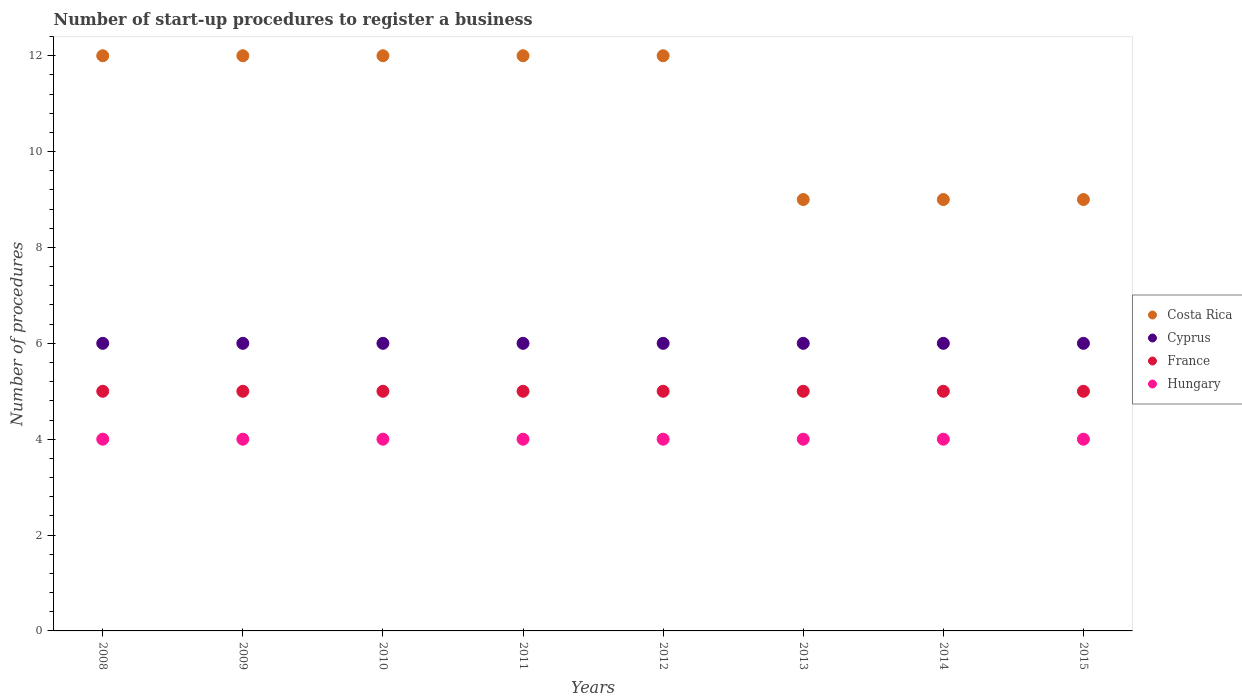Is the number of dotlines equal to the number of legend labels?
Offer a terse response. Yes. What is the number of procedures required to register a business in Hungary in 2010?
Your answer should be compact. 4. Across all years, what is the maximum number of procedures required to register a business in France?
Keep it short and to the point. 5. Across all years, what is the minimum number of procedures required to register a business in Cyprus?
Give a very brief answer. 6. In which year was the number of procedures required to register a business in Cyprus minimum?
Your answer should be compact. 2008. What is the total number of procedures required to register a business in Cyprus in the graph?
Keep it short and to the point. 48. What is the difference between the number of procedures required to register a business in Cyprus in 2010 and that in 2011?
Your answer should be compact. 0. What is the average number of procedures required to register a business in Costa Rica per year?
Offer a very short reply. 10.88. In how many years, is the number of procedures required to register a business in Hungary greater than 10.4?
Provide a succinct answer. 0. Is the difference between the number of procedures required to register a business in Hungary in 2013 and 2014 greater than the difference between the number of procedures required to register a business in Cyprus in 2013 and 2014?
Make the answer very short. No. What is the difference between the highest and the lowest number of procedures required to register a business in Costa Rica?
Offer a very short reply. 3. In how many years, is the number of procedures required to register a business in Cyprus greater than the average number of procedures required to register a business in Cyprus taken over all years?
Make the answer very short. 0. Does the number of procedures required to register a business in Costa Rica monotonically increase over the years?
Make the answer very short. No. Is the number of procedures required to register a business in Hungary strictly greater than the number of procedures required to register a business in France over the years?
Make the answer very short. No. How many dotlines are there?
Provide a short and direct response. 4. What is the difference between two consecutive major ticks on the Y-axis?
Offer a very short reply. 2. Does the graph contain any zero values?
Provide a succinct answer. No. What is the title of the graph?
Offer a very short reply. Number of start-up procedures to register a business. What is the label or title of the Y-axis?
Give a very brief answer. Number of procedures. What is the Number of procedures of France in 2008?
Offer a terse response. 5. What is the Number of procedures in Hungary in 2008?
Ensure brevity in your answer.  4. What is the Number of procedures in Costa Rica in 2009?
Make the answer very short. 12. What is the Number of procedures in Cyprus in 2009?
Make the answer very short. 6. What is the Number of procedures in France in 2010?
Give a very brief answer. 5. What is the Number of procedures in Hungary in 2010?
Ensure brevity in your answer.  4. What is the Number of procedures of Cyprus in 2011?
Make the answer very short. 6. What is the Number of procedures of France in 2011?
Provide a short and direct response. 5. What is the Number of procedures of Costa Rica in 2012?
Provide a short and direct response. 12. What is the Number of procedures in France in 2012?
Ensure brevity in your answer.  5. What is the Number of procedures of Costa Rica in 2013?
Keep it short and to the point. 9. What is the Number of procedures in Hungary in 2013?
Provide a short and direct response. 4. What is the Number of procedures of Cyprus in 2014?
Ensure brevity in your answer.  6. What is the Number of procedures in Costa Rica in 2015?
Offer a very short reply. 9. What is the Number of procedures of Cyprus in 2015?
Give a very brief answer. 6. Across all years, what is the maximum Number of procedures of France?
Give a very brief answer. 5. Across all years, what is the maximum Number of procedures of Hungary?
Keep it short and to the point. 4. Across all years, what is the minimum Number of procedures of Costa Rica?
Offer a very short reply. 9. What is the total Number of procedures in France in the graph?
Provide a succinct answer. 40. What is the difference between the Number of procedures of Costa Rica in 2008 and that in 2009?
Provide a short and direct response. 0. What is the difference between the Number of procedures in Cyprus in 2008 and that in 2010?
Ensure brevity in your answer.  0. What is the difference between the Number of procedures of France in 2008 and that in 2010?
Make the answer very short. 0. What is the difference between the Number of procedures in France in 2008 and that in 2011?
Keep it short and to the point. 0. What is the difference between the Number of procedures of Hungary in 2008 and that in 2011?
Your answer should be very brief. 0. What is the difference between the Number of procedures of Costa Rica in 2008 and that in 2012?
Provide a short and direct response. 0. What is the difference between the Number of procedures of Cyprus in 2008 and that in 2012?
Give a very brief answer. 0. What is the difference between the Number of procedures in France in 2008 and that in 2012?
Provide a short and direct response. 0. What is the difference between the Number of procedures of France in 2008 and that in 2013?
Your answer should be compact. 0. What is the difference between the Number of procedures of Hungary in 2008 and that in 2013?
Your answer should be compact. 0. What is the difference between the Number of procedures of Hungary in 2008 and that in 2014?
Make the answer very short. 0. What is the difference between the Number of procedures in Costa Rica in 2009 and that in 2010?
Give a very brief answer. 0. What is the difference between the Number of procedures of France in 2009 and that in 2010?
Make the answer very short. 0. What is the difference between the Number of procedures of Cyprus in 2009 and that in 2011?
Offer a very short reply. 0. What is the difference between the Number of procedures in France in 2009 and that in 2011?
Give a very brief answer. 0. What is the difference between the Number of procedures of Hungary in 2009 and that in 2011?
Offer a terse response. 0. What is the difference between the Number of procedures of Costa Rica in 2009 and that in 2012?
Offer a very short reply. 0. What is the difference between the Number of procedures of Cyprus in 2009 and that in 2012?
Keep it short and to the point. 0. What is the difference between the Number of procedures in Costa Rica in 2009 and that in 2013?
Your answer should be very brief. 3. What is the difference between the Number of procedures of France in 2009 and that in 2014?
Your answer should be very brief. 0. What is the difference between the Number of procedures in Hungary in 2009 and that in 2015?
Your response must be concise. 0. What is the difference between the Number of procedures in Costa Rica in 2010 and that in 2011?
Keep it short and to the point. 0. What is the difference between the Number of procedures of Hungary in 2010 and that in 2011?
Keep it short and to the point. 0. What is the difference between the Number of procedures in Cyprus in 2010 and that in 2012?
Provide a succinct answer. 0. What is the difference between the Number of procedures of Hungary in 2010 and that in 2012?
Offer a terse response. 0. What is the difference between the Number of procedures of Costa Rica in 2010 and that in 2013?
Give a very brief answer. 3. What is the difference between the Number of procedures of Cyprus in 2010 and that in 2013?
Make the answer very short. 0. What is the difference between the Number of procedures in Hungary in 2010 and that in 2013?
Make the answer very short. 0. What is the difference between the Number of procedures in Costa Rica in 2010 and that in 2014?
Offer a very short reply. 3. What is the difference between the Number of procedures in Hungary in 2010 and that in 2014?
Provide a short and direct response. 0. What is the difference between the Number of procedures in Costa Rica in 2010 and that in 2015?
Offer a terse response. 3. What is the difference between the Number of procedures of Cyprus in 2010 and that in 2015?
Ensure brevity in your answer.  0. What is the difference between the Number of procedures of Hungary in 2010 and that in 2015?
Give a very brief answer. 0. What is the difference between the Number of procedures in Costa Rica in 2011 and that in 2012?
Your response must be concise. 0. What is the difference between the Number of procedures in Hungary in 2011 and that in 2012?
Your answer should be compact. 0. What is the difference between the Number of procedures in Costa Rica in 2011 and that in 2013?
Ensure brevity in your answer.  3. What is the difference between the Number of procedures in France in 2011 and that in 2014?
Offer a terse response. 0. What is the difference between the Number of procedures in Cyprus in 2011 and that in 2015?
Give a very brief answer. 0. What is the difference between the Number of procedures in Hungary in 2011 and that in 2015?
Make the answer very short. 0. What is the difference between the Number of procedures of France in 2012 and that in 2013?
Offer a terse response. 0. What is the difference between the Number of procedures in France in 2012 and that in 2014?
Offer a very short reply. 0. What is the difference between the Number of procedures in Hungary in 2012 and that in 2015?
Make the answer very short. 0. What is the difference between the Number of procedures in France in 2013 and that in 2014?
Provide a short and direct response. 0. What is the difference between the Number of procedures of France in 2013 and that in 2015?
Provide a short and direct response. 0. What is the difference between the Number of procedures of Cyprus in 2014 and that in 2015?
Your answer should be very brief. 0. What is the difference between the Number of procedures of France in 2014 and that in 2015?
Keep it short and to the point. 0. What is the difference between the Number of procedures in Hungary in 2014 and that in 2015?
Offer a very short reply. 0. What is the difference between the Number of procedures of Costa Rica in 2008 and the Number of procedures of Cyprus in 2009?
Provide a short and direct response. 6. What is the difference between the Number of procedures of Costa Rica in 2008 and the Number of procedures of France in 2009?
Make the answer very short. 7. What is the difference between the Number of procedures of Cyprus in 2008 and the Number of procedures of France in 2009?
Your response must be concise. 1. What is the difference between the Number of procedures of France in 2008 and the Number of procedures of Hungary in 2009?
Provide a succinct answer. 1. What is the difference between the Number of procedures of Costa Rica in 2008 and the Number of procedures of France in 2010?
Your answer should be very brief. 7. What is the difference between the Number of procedures in Costa Rica in 2008 and the Number of procedures in Hungary in 2010?
Make the answer very short. 8. What is the difference between the Number of procedures in Cyprus in 2008 and the Number of procedures in France in 2010?
Offer a terse response. 1. What is the difference between the Number of procedures of Cyprus in 2008 and the Number of procedures of Hungary in 2010?
Provide a short and direct response. 2. What is the difference between the Number of procedures in France in 2008 and the Number of procedures in Hungary in 2010?
Provide a short and direct response. 1. What is the difference between the Number of procedures of Costa Rica in 2008 and the Number of procedures of Cyprus in 2011?
Provide a succinct answer. 6. What is the difference between the Number of procedures of Costa Rica in 2008 and the Number of procedures of France in 2011?
Give a very brief answer. 7. What is the difference between the Number of procedures of Costa Rica in 2008 and the Number of procedures of Hungary in 2011?
Your response must be concise. 8. What is the difference between the Number of procedures in Cyprus in 2008 and the Number of procedures in France in 2011?
Offer a very short reply. 1. What is the difference between the Number of procedures of Costa Rica in 2008 and the Number of procedures of Cyprus in 2012?
Ensure brevity in your answer.  6. What is the difference between the Number of procedures in Cyprus in 2008 and the Number of procedures in Hungary in 2012?
Offer a terse response. 2. What is the difference between the Number of procedures in Costa Rica in 2008 and the Number of procedures in France in 2013?
Make the answer very short. 7. What is the difference between the Number of procedures in France in 2008 and the Number of procedures in Hungary in 2013?
Your answer should be very brief. 1. What is the difference between the Number of procedures in Costa Rica in 2008 and the Number of procedures in Cyprus in 2014?
Give a very brief answer. 6. What is the difference between the Number of procedures of Costa Rica in 2008 and the Number of procedures of Hungary in 2014?
Your response must be concise. 8. What is the difference between the Number of procedures in Cyprus in 2008 and the Number of procedures in France in 2014?
Offer a terse response. 1. What is the difference between the Number of procedures of Cyprus in 2008 and the Number of procedures of Hungary in 2014?
Your answer should be compact. 2. What is the difference between the Number of procedures in Cyprus in 2008 and the Number of procedures in Hungary in 2015?
Make the answer very short. 2. What is the difference between the Number of procedures in France in 2008 and the Number of procedures in Hungary in 2015?
Keep it short and to the point. 1. What is the difference between the Number of procedures in Costa Rica in 2009 and the Number of procedures in Cyprus in 2010?
Offer a very short reply. 6. What is the difference between the Number of procedures in Costa Rica in 2009 and the Number of procedures in France in 2010?
Make the answer very short. 7. What is the difference between the Number of procedures of Cyprus in 2009 and the Number of procedures of Hungary in 2010?
Your response must be concise. 2. What is the difference between the Number of procedures in Cyprus in 2009 and the Number of procedures in Hungary in 2011?
Offer a terse response. 2. What is the difference between the Number of procedures of Costa Rica in 2009 and the Number of procedures of France in 2012?
Give a very brief answer. 7. What is the difference between the Number of procedures in Cyprus in 2009 and the Number of procedures in France in 2013?
Keep it short and to the point. 1. What is the difference between the Number of procedures in Costa Rica in 2009 and the Number of procedures in Cyprus in 2014?
Your answer should be very brief. 6. What is the difference between the Number of procedures in Costa Rica in 2009 and the Number of procedures in France in 2014?
Your response must be concise. 7. What is the difference between the Number of procedures in Costa Rica in 2009 and the Number of procedures in Hungary in 2014?
Offer a terse response. 8. What is the difference between the Number of procedures of Cyprus in 2009 and the Number of procedures of France in 2014?
Your answer should be very brief. 1. What is the difference between the Number of procedures of Cyprus in 2009 and the Number of procedures of Hungary in 2014?
Your response must be concise. 2. What is the difference between the Number of procedures of France in 2009 and the Number of procedures of Hungary in 2014?
Your answer should be compact. 1. What is the difference between the Number of procedures of Costa Rica in 2009 and the Number of procedures of Cyprus in 2015?
Offer a terse response. 6. What is the difference between the Number of procedures of Costa Rica in 2010 and the Number of procedures of Hungary in 2011?
Keep it short and to the point. 8. What is the difference between the Number of procedures of France in 2010 and the Number of procedures of Hungary in 2011?
Your response must be concise. 1. What is the difference between the Number of procedures of Costa Rica in 2010 and the Number of procedures of France in 2012?
Give a very brief answer. 7. What is the difference between the Number of procedures of France in 2010 and the Number of procedures of Hungary in 2012?
Your answer should be compact. 1. What is the difference between the Number of procedures of Costa Rica in 2010 and the Number of procedures of France in 2013?
Keep it short and to the point. 7. What is the difference between the Number of procedures in Cyprus in 2010 and the Number of procedures in France in 2013?
Ensure brevity in your answer.  1. What is the difference between the Number of procedures in France in 2010 and the Number of procedures in Hungary in 2013?
Your response must be concise. 1. What is the difference between the Number of procedures in Costa Rica in 2010 and the Number of procedures in Cyprus in 2014?
Make the answer very short. 6. What is the difference between the Number of procedures in Costa Rica in 2010 and the Number of procedures in Cyprus in 2015?
Make the answer very short. 6. What is the difference between the Number of procedures of Costa Rica in 2010 and the Number of procedures of France in 2015?
Make the answer very short. 7. What is the difference between the Number of procedures in Costa Rica in 2011 and the Number of procedures in Cyprus in 2012?
Your answer should be compact. 6. What is the difference between the Number of procedures of Costa Rica in 2011 and the Number of procedures of France in 2012?
Give a very brief answer. 7. What is the difference between the Number of procedures in Cyprus in 2011 and the Number of procedures in France in 2012?
Offer a terse response. 1. What is the difference between the Number of procedures of Cyprus in 2011 and the Number of procedures of France in 2013?
Offer a very short reply. 1. What is the difference between the Number of procedures of Cyprus in 2011 and the Number of procedures of Hungary in 2013?
Offer a very short reply. 2. What is the difference between the Number of procedures of France in 2011 and the Number of procedures of Hungary in 2013?
Your answer should be very brief. 1. What is the difference between the Number of procedures of Cyprus in 2011 and the Number of procedures of France in 2014?
Offer a terse response. 1. What is the difference between the Number of procedures in Cyprus in 2011 and the Number of procedures in Hungary in 2014?
Make the answer very short. 2. What is the difference between the Number of procedures of France in 2011 and the Number of procedures of Hungary in 2014?
Your answer should be very brief. 1. What is the difference between the Number of procedures in Costa Rica in 2011 and the Number of procedures in France in 2015?
Keep it short and to the point. 7. What is the difference between the Number of procedures of France in 2011 and the Number of procedures of Hungary in 2015?
Offer a very short reply. 1. What is the difference between the Number of procedures of Costa Rica in 2012 and the Number of procedures of France in 2013?
Make the answer very short. 7. What is the difference between the Number of procedures of Costa Rica in 2012 and the Number of procedures of Hungary in 2014?
Offer a very short reply. 8. What is the difference between the Number of procedures of Cyprus in 2012 and the Number of procedures of Hungary in 2015?
Your response must be concise. 2. What is the difference between the Number of procedures of France in 2012 and the Number of procedures of Hungary in 2015?
Provide a succinct answer. 1. What is the difference between the Number of procedures in Costa Rica in 2013 and the Number of procedures in Cyprus in 2014?
Make the answer very short. 3. What is the difference between the Number of procedures of Costa Rica in 2013 and the Number of procedures of France in 2014?
Make the answer very short. 4. What is the difference between the Number of procedures in Costa Rica in 2013 and the Number of procedures in Hungary in 2014?
Provide a short and direct response. 5. What is the difference between the Number of procedures in Costa Rica in 2013 and the Number of procedures in France in 2015?
Offer a terse response. 4. What is the difference between the Number of procedures in Costa Rica in 2013 and the Number of procedures in Hungary in 2015?
Your response must be concise. 5. What is the difference between the Number of procedures of Costa Rica in 2014 and the Number of procedures of Cyprus in 2015?
Offer a terse response. 3. What is the difference between the Number of procedures of Costa Rica in 2014 and the Number of procedures of Hungary in 2015?
Make the answer very short. 5. What is the difference between the Number of procedures of Cyprus in 2014 and the Number of procedures of France in 2015?
Provide a short and direct response. 1. What is the difference between the Number of procedures of France in 2014 and the Number of procedures of Hungary in 2015?
Your response must be concise. 1. What is the average Number of procedures in Costa Rica per year?
Your answer should be very brief. 10.88. What is the average Number of procedures in Cyprus per year?
Your answer should be very brief. 6. In the year 2008, what is the difference between the Number of procedures of Costa Rica and Number of procedures of Cyprus?
Make the answer very short. 6. In the year 2008, what is the difference between the Number of procedures in Costa Rica and Number of procedures in Hungary?
Offer a very short reply. 8. In the year 2008, what is the difference between the Number of procedures of Cyprus and Number of procedures of France?
Offer a very short reply. 1. In the year 2008, what is the difference between the Number of procedures of Cyprus and Number of procedures of Hungary?
Offer a very short reply. 2. In the year 2008, what is the difference between the Number of procedures in France and Number of procedures in Hungary?
Your response must be concise. 1. In the year 2009, what is the difference between the Number of procedures in Costa Rica and Number of procedures in Hungary?
Provide a short and direct response. 8. In the year 2009, what is the difference between the Number of procedures in Cyprus and Number of procedures in France?
Give a very brief answer. 1. In the year 2009, what is the difference between the Number of procedures of France and Number of procedures of Hungary?
Provide a short and direct response. 1. In the year 2010, what is the difference between the Number of procedures of Cyprus and Number of procedures of France?
Your answer should be compact. 1. In the year 2011, what is the difference between the Number of procedures in Costa Rica and Number of procedures in Cyprus?
Provide a short and direct response. 6. In the year 2011, what is the difference between the Number of procedures of Costa Rica and Number of procedures of Hungary?
Make the answer very short. 8. In the year 2011, what is the difference between the Number of procedures of Cyprus and Number of procedures of Hungary?
Keep it short and to the point. 2. In the year 2012, what is the difference between the Number of procedures of Costa Rica and Number of procedures of Cyprus?
Provide a succinct answer. 6. In the year 2012, what is the difference between the Number of procedures in France and Number of procedures in Hungary?
Your answer should be compact. 1. In the year 2013, what is the difference between the Number of procedures of Costa Rica and Number of procedures of Cyprus?
Offer a very short reply. 3. In the year 2013, what is the difference between the Number of procedures in Cyprus and Number of procedures in France?
Offer a terse response. 1. In the year 2014, what is the difference between the Number of procedures in Costa Rica and Number of procedures in France?
Ensure brevity in your answer.  4. In the year 2014, what is the difference between the Number of procedures of Costa Rica and Number of procedures of Hungary?
Offer a terse response. 5. In the year 2014, what is the difference between the Number of procedures in Cyprus and Number of procedures in France?
Make the answer very short. 1. In the year 2014, what is the difference between the Number of procedures in Cyprus and Number of procedures in Hungary?
Make the answer very short. 2. In the year 2014, what is the difference between the Number of procedures of France and Number of procedures of Hungary?
Your answer should be very brief. 1. In the year 2015, what is the difference between the Number of procedures of Costa Rica and Number of procedures of Cyprus?
Offer a terse response. 3. In the year 2015, what is the difference between the Number of procedures of Costa Rica and Number of procedures of France?
Provide a short and direct response. 4. In the year 2015, what is the difference between the Number of procedures of Costa Rica and Number of procedures of Hungary?
Ensure brevity in your answer.  5. In the year 2015, what is the difference between the Number of procedures of Cyprus and Number of procedures of Hungary?
Make the answer very short. 2. In the year 2015, what is the difference between the Number of procedures in France and Number of procedures in Hungary?
Ensure brevity in your answer.  1. What is the ratio of the Number of procedures in Costa Rica in 2008 to that in 2009?
Your answer should be very brief. 1. What is the ratio of the Number of procedures of Cyprus in 2008 to that in 2009?
Offer a terse response. 1. What is the ratio of the Number of procedures of France in 2008 to that in 2010?
Keep it short and to the point. 1. What is the ratio of the Number of procedures of Costa Rica in 2008 to that in 2011?
Your response must be concise. 1. What is the ratio of the Number of procedures in France in 2008 to that in 2011?
Offer a terse response. 1. What is the ratio of the Number of procedures of Cyprus in 2008 to that in 2012?
Provide a short and direct response. 1. What is the ratio of the Number of procedures of Costa Rica in 2008 to that in 2013?
Offer a very short reply. 1.33. What is the ratio of the Number of procedures of Cyprus in 2008 to that in 2013?
Your response must be concise. 1. What is the ratio of the Number of procedures of Costa Rica in 2008 to that in 2014?
Ensure brevity in your answer.  1.33. What is the ratio of the Number of procedures in Cyprus in 2008 to that in 2014?
Give a very brief answer. 1. What is the ratio of the Number of procedures in France in 2008 to that in 2014?
Your answer should be very brief. 1. What is the ratio of the Number of procedures of Hungary in 2008 to that in 2014?
Offer a very short reply. 1. What is the ratio of the Number of procedures of Costa Rica in 2008 to that in 2015?
Your answer should be very brief. 1.33. What is the ratio of the Number of procedures in Cyprus in 2008 to that in 2015?
Offer a terse response. 1. What is the ratio of the Number of procedures in France in 2008 to that in 2015?
Make the answer very short. 1. What is the ratio of the Number of procedures of Cyprus in 2009 to that in 2010?
Offer a terse response. 1. What is the ratio of the Number of procedures of Hungary in 2009 to that in 2010?
Offer a very short reply. 1. What is the ratio of the Number of procedures of Costa Rica in 2009 to that in 2011?
Your answer should be very brief. 1. What is the ratio of the Number of procedures of France in 2009 to that in 2011?
Offer a terse response. 1. What is the ratio of the Number of procedures of Hungary in 2009 to that in 2011?
Your answer should be very brief. 1. What is the ratio of the Number of procedures in France in 2009 to that in 2012?
Your response must be concise. 1. What is the ratio of the Number of procedures in Cyprus in 2009 to that in 2013?
Offer a very short reply. 1. What is the ratio of the Number of procedures of Hungary in 2009 to that in 2013?
Offer a very short reply. 1. What is the ratio of the Number of procedures of Costa Rica in 2009 to that in 2014?
Give a very brief answer. 1.33. What is the ratio of the Number of procedures of France in 2009 to that in 2014?
Offer a terse response. 1. What is the ratio of the Number of procedures of Cyprus in 2009 to that in 2015?
Give a very brief answer. 1. What is the ratio of the Number of procedures in France in 2009 to that in 2015?
Your answer should be compact. 1. What is the ratio of the Number of procedures in Costa Rica in 2010 to that in 2011?
Keep it short and to the point. 1. What is the ratio of the Number of procedures in Hungary in 2010 to that in 2011?
Offer a terse response. 1. What is the ratio of the Number of procedures in Hungary in 2010 to that in 2012?
Keep it short and to the point. 1. What is the ratio of the Number of procedures of Cyprus in 2010 to that in 2013?
Your answer should be compact. 1. What is the ratio of the Number of procedures in Hungary in 2010 to that in 2013?
Keep it short and to the point. 1. What is the ratio of the Number of procedures in Costa Rica in 2010 to that in 2014?
Your answer should be compact. 1.33. What is the ratio of the Number of procedures in Cyprus in 2010 to that in 2014?
Your answer should be compact. 1. What is the ratio of the Number of procedures of France in 2010 to that in 2014?
Give a very brief answer. 1. What is the ratio of the Number of procedures in Cyprus in 2010 to that in 2015?
Ensure brevity in your answer.  1. What is the ratio of the Number of procedures in Hungary in 2010 to that in 2015?
Offer a terse response. 1. What is the ratio of the Number of procedures of Costa Rica in 2011 to that in 2012?
Give a very brief answer. 1. What is the ratio of the Number of procedures in France in 2011 to that in 2012?
Make the answer very short. 1. What is the ratio of the Number of procedures of Cyprus in 2011 to that in 2013?
Give a very brief answer. 1. What is the ratio of the Number of procedures in Hungary in 2011 to that in 2013?
Give a very brief answer. 1. What is the ratio of the Number of procedures of Costa Rica in 2011 to that in 2014?
Make the answer very short. 1.33. What is the ratio of the Number of procedures in France in 2011 to that in 2014?
Your answer should be compact. 1. What is the ratio of the Number of procedures in Costa Rica in 2011 to that in 2015?
Offer a terse response. 1.33. What is the ratio of the Number of procedures of Cyprus in 2011 to that in 2015?
Provide a short and direct response. 1. What is the ratio of the Number of procedures of Costa Rica in 2012 to that in 2013?
Offer a terse response. 1.33. What is the ratio of the Number of procedures of Cyprus in 2012 to that in 2014?
Provide a succinct answer. 1. What is the ratio of the Number of procedures in France in 2012 to that in 2014?
Provide a short and direct response. 1. What is the ratio of the Number of procedures in Costa Rica in 2012 to that in 2015?
Offer a terse response. 1.33. What is the ratio of the Number of procedures of Cyprus in 2012 to that in 2015?
Make the answer very short. 1. What is the ratio of the Number of procedures in Cyprus in 2013 to that in 2014?
Your response must be concise. 1. What is the ratio of the Number of procedures in Hungary in 2013 to that in 2014?
Give a very brief answer. 1. What is the ratio of the Number of procedures of Costa Rica in 2013 to that in 2015?
Ensure brevity in your answer.  1. What is the ratio of the Number of procedures of Costa Rica in 2014 to that in 2015?
Your response must be concise. 1. What is the ratio of the Number of procedures in Hungary in 2014 to that in 2015?
Provide a short and direct response. 1. What is the difference between the highest and the lowest Number of procedures in Costa Rica?
Give a very brief answer. 3. 